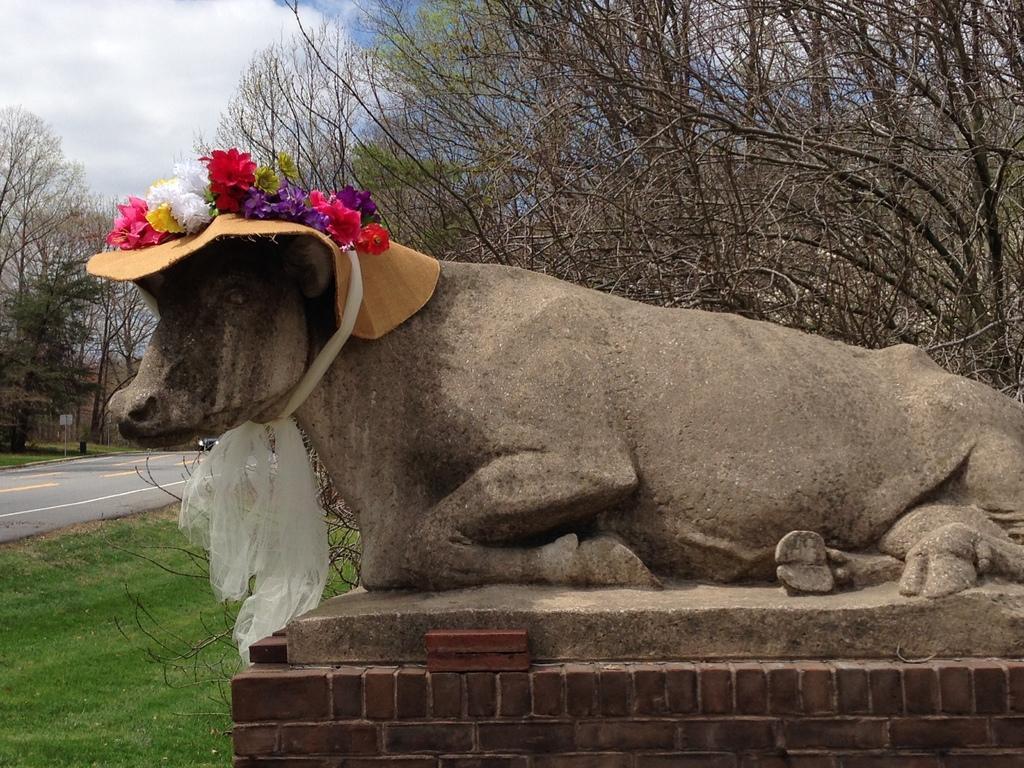In one or two sentences, can you explain what this image depicts? To the statue there is a ribbon and flowers. In the background of the image there are trees, cloudy sky, road, board and grass.   